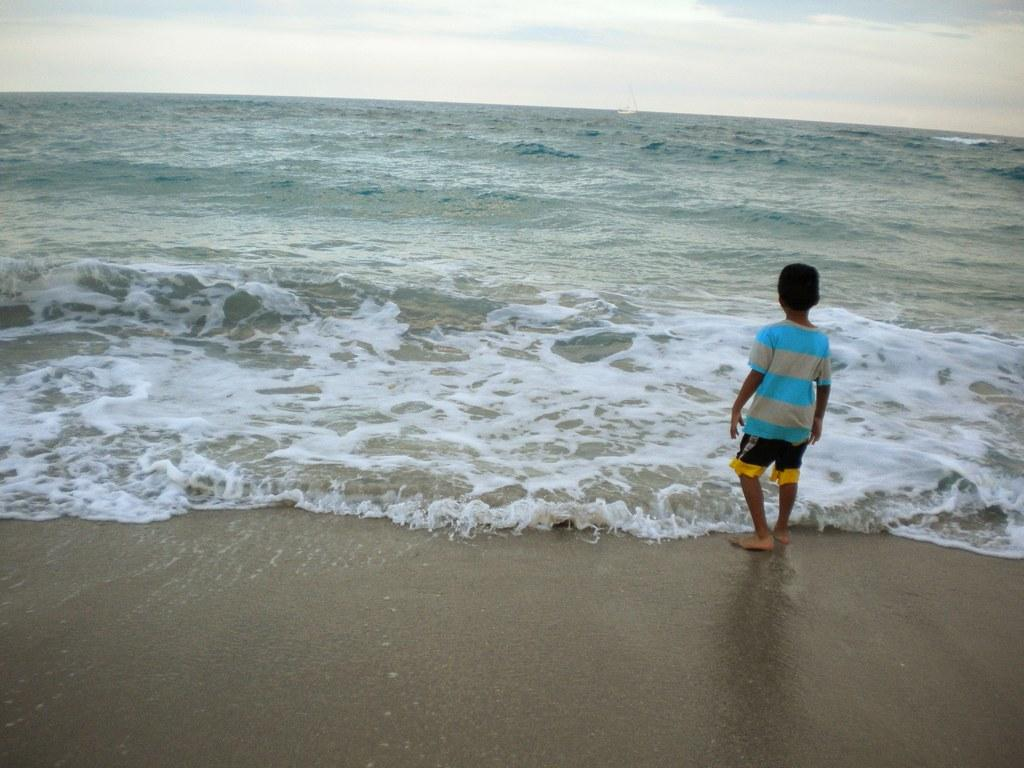What is the person in the image doing? The person is standing in front of the water. Can you describe the person's outfit? The person is wearing a dress with blue, ash, black, and yellow colors. What can be seen in the background of the image? The sky is visible in the background of the image. What is the weight of the structure visible in the image? There is no structure visible in the image; it only features a person standing in front of the water. 